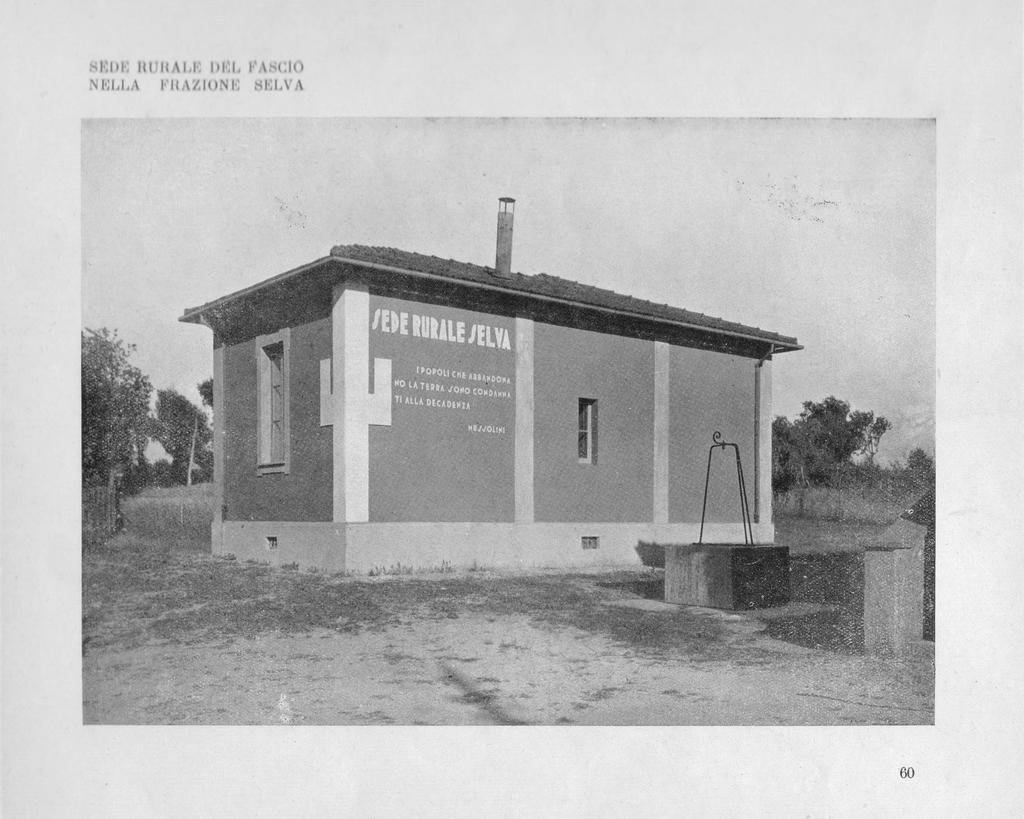What is present in the image that can be written or read on? There is a paper in the image that can be written or read on. What is the main structure in the center of the image? There is a building in the center of the image. What type of natural elements can be seen in the background? There are trees in the background of the image. What is visible at the top of the image? The sky is visible at the top of the image. What can be found on the paper in the image? There is text written in the image. How many icicles are hanging from the building in the image? There are no icicles present in the image; it features a building, trees, and text on a paper. What type of story is being told by the power lines in the image? There are no power lines or storytelling elements in the image; it features a building, trees, and text on a paper. 